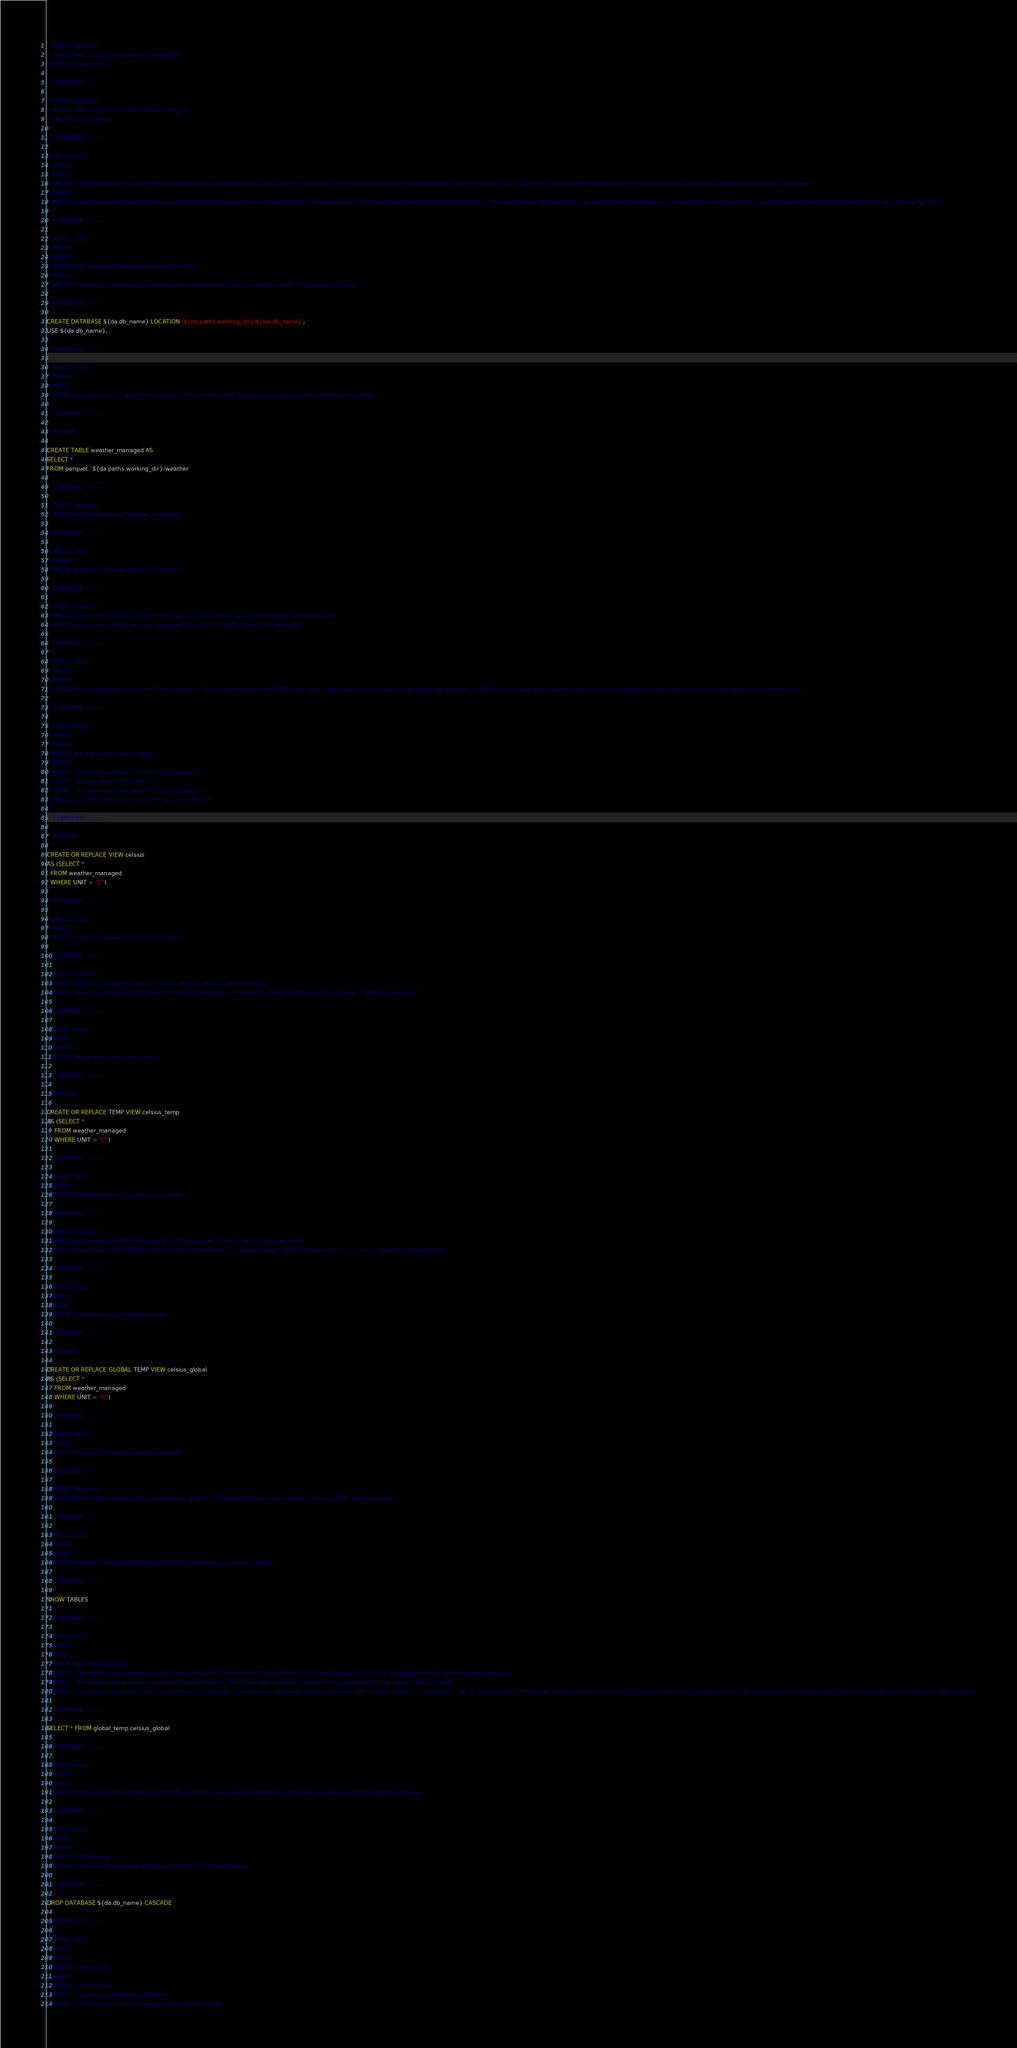Convert code to text. <code><loc_0><loc_0><loc_500><loc_500><_SQL_>
-- MAGIC %python
-- MAGIC files = dbutils.fs.ls(externalTablePath)
-- MAGIC display(files)

-- COMMAND ----------

-- MAGIC %python
-- MAGIC files = dbutils.fs.ls(DA.paths.working_dir)
-- MAGIC display(files)

-- COMMAND ----------

-- MAGIC %md
-- MAGIC 
-- MAGIC 
-- MAGIC **This highlights the main differences between managed and external tables.** By default, the files associated with managed tables will be stored to this location on the root DBFS storage linked to the workspace, and will be deleted when a table is dropped.
-- MAGIC 
-- MAGIC Files for external tables will be persisted in the location provided at table creation, preventing users from inadvertently deleting underlying files. **External tables can easily be migrated to other databases or renamed, but these operations with managed tables will require rewriting ALL underlying files.**

-- COMMAND ----------

-- MAGIC %md
-- MAGIC 
-- MAGIC 
-- MAGIC ## Create a Database with a Specified Path
-- MAGIC 
-- MAGIC Assuming you dropped your database in the last step, you can use the same **`database`** name.

-- COMMAND ----------

CREATE DATABASE ${da.db_name} LOCATION '${da.paths.working_dir}/${da.db_name}';
USE ${da.db_name};

-- COMMAND ----------

-- MAGIC %md
-- MAGIC 
-- MAGIC 
-- MAGIC Recreate your **`weather_managed`** table in this new database and print out the location of this table.

-- COMMAND ----------

-- ANSWER

CREATE TABLE weather_managed AS
SELECT * 
FROM parquet.`${da.paths.working_dir}/weather`

-- COMMAND ----------

-- MAGIC %python
-- MAGIC getTableLocation("weather_managed")

-- COMMAND ----------

-- MAGIC %md
-- MAGIC 
-- MAGIC Run the cell below to check your work.

-- COMMAND ----------

-- MAGIC %python
-- MAGIC assert spark.table("weather_managed"), "Table named `weather_managed` does not exist"
-- MAGIC assert spark.table("weather_managed").count() == 2559, "Incorrect row count"

-- COMMAND ----------

-- MAGIC %md
-- MAGIC 
-- MAGIC 
-- MAGIC While here we're using the **`working_dir`** directory created on the DBFS root, _any_ object store can be used as the database directory. **Defining database directories for groups of users can greatly reduce the chances of accidental data exfiltration**.

-- COMMAND ----------

-- MAGIC %md
-- MAGIC 
-- MAGIC 
-- MAGIC ## Views and their Scoping
-- MAGIC 
-- MAGIC Using the provided **`AS`** clause, register:
-- MAGIC - a view named **`celsius`**
-- MAGIC - a temporary view named **`celsius_temp`**
-- MAGIC - a global temp view named **`celsius_global`**

-- COMMAND ----------

-- ANSWER

CREATE OR REPLACE VIEW celsius
AS (SELECT *
  FROM weather_managed
  WHERE UNIT = "C")

-- COMMAND ----------

-- MAGIC %md
-- MAGIC 
-- MAGIC Run the cell below to check your work.

-- COMMAND ----------

-- MAGIC %python
-- MAGIC assert spark.table("celsius"), "Table named `celsius` does not exist"
-- MAGIC assert spark.sql(f"SHOW TABLES").filter(f"tableName == 'celsius'").first()["isTemporary"] == False, "Table is temporary"

-- COMMAND ----------

-- MAGIC %md
-- MAGIC 
-- MAGIC 
-- MAGIC Now create a temporary view.

-- COMMAND ----------

-- ANSWER

CREATE OR REPLACE TEMP VIEW celsius_temp
AS (SELECT *
    FROM weather_managed
    WHERE UNIT = "C")

-- COMMAND ----------

-- MAGIC %md
-- MAGIC 
-- MAGIC Run the cell below to check your work.

-- COMMAND ----------

-- MAGIC %python
-- MAGIC assert spark.table("celsius_temp"), "Table named `celsius_temp` does not exist"
-- MAGIC assert spark.sql(f"SHOW TABLES").filter(f"tableName == 'celsius_temp'").first()["isTemporary"] == True, "Table is not temporary"

-- COMMAND ----------

-- MAGIC %md
-- MAGIC 
-- MAGIC 
-- MAGIC Now register a global temp view.

-- COMMAND ----------

-- ANSWER

CREATE OR REPLACE GLOBAL TEMP VIEW celsius_global
AS (SELECT *
    FROM weather_managed
    WHERE UNIT = "C")

-- COMMAND ----------

-- MAGIC %md
-- MAGIC 
-- MAGIC Run the cell below to check your work.

-- COMMAND ----------

-- MAGIC %python
-- MAGIC assert spark.table("global_temp.celsius_global"), "Global temporary view named `celsius_global` does not exist"

-- COMMAND ----------

-- MAGIC %md
-- MAGIC 
-- MAGIC 
-- MAGIC Views will be displayed alongside tables when listing from the catalog.

-- COMMAND ----------

SHOW TABLES

-- COMMAND ----------

-- MAGIC %md
-- MAGIC 
-- MAGIC 
-- MAGIC Note the following:
-- MAGIC - The view is associated with the current database. This view will be available to any user that can access this database and will persist between sessions.
-- MAGIC - The temp view is not associated with any database. The temp view is ephemeral and is only accessible in the current SparkSession.
-- MAGIC - The global temp view does not appear in our catalog. **Global temp views will always register to the **`global_temp`** database**. The **`global_temp`** database is ephemeral but tied to the lifetime of the cluster; however, it is only accessible by notebooks attached to the same cluster on which it was created.

-- COMMAND ----------

SELECT * FROM global_temp.celsius_global

-- COMMAND ----------

-- MAGIC %md
-- MAGIC 
-- MAGIC 
-- MAGIC While no job was triggered when defining these views, a job is triggered _each time_ a query is executed against the view.

-- COMMAND ----------

-- MAGIC %md
-- MAGIC 
-- MAGIC 
-- MAGIC ## Clean Up
-- MAGIC Drop the database and all tables to clean up your workspace.

-- COMMAND ----------

DROP DATABASE ${da.db_name} CASCADE

-- COMMAND ----------

-- MAGIC %md
-- MAGIC 
-- MAGIC 
-- MAGIC ## Synopsis
-- MAGIC 
-- MAGIC In this lab we:
-- MAGIC - Created and deleted databases
-- MAGIC - Explored behavior of managed and external tables</code> 